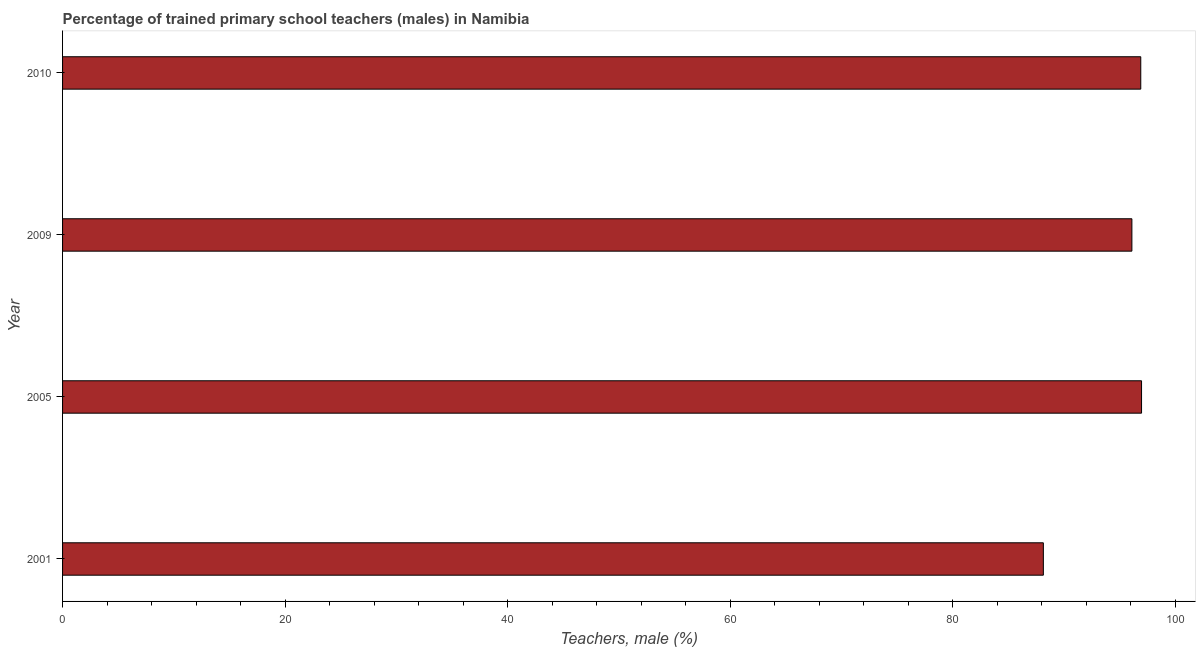Does the graph contain grids?
Give a very brief answer. No. What is the title of the graph?
Your answer should be compact. Percentage of trained primary school teachers (males) in Namibia. What is the label or title of the X-axis?
Offer a very short reply. Teachers, male (%). What is the label or title of the Y-axis?
Make the answer very short. Year. What is the percentage of trained male teachers in 2010?
Keep it short and to the point. 96.92. Across all years, what is the maximum percentage of trained male teachers?
Offer a very short reply. 96.99. Across all years, what is the minimum percentage of trained male teachers?
Keep it short and to the point. 88.16. What is the sum of the percentage of trained male teachers?
Your answer should be compact. 378.19. What is the difference between the percentage of trained male teachers in 2005 and 2009?
Ensure brevity in your answer.  0.87. What is the average percentage of trained male teachers per year?
Offer a very short reply. 94.55. What is the median percentage of trained male teachers?
Keep it short and to the point. 96.52. Do a majority of the years between 2001 and 2005 (inclusive) have percentage of trained male teachers greater than 32 %?
Give a very brief answer. Yes. What is the ratio of the percentage of trained male teachers in 2001 to that in 2010?
Offer a very short reply. 0.91. Is the difference between the percentage of trained male teachers in 2001 and 2005 greater than the difference between any two years?
Your response must be concise. Yes. What is the difference between the highest and the second highest percentage of trained male teachers?
Make the answer very short. 0.07. Is the sum of the percentage of trained male teachers in 2001 and 2009 greater than the maximum percentage of trained male teachers across all years?
Provide a succinct answer. Yes. What is the difference between the highest and the lowest percentage of trained male teachers?
Offer a terse response. 8.83. In how many years, is the percentage of trained male teachers greater than the average percentage of trained male teachers taken over all years?
Offer a terse response. 3. What is the Teachers, male (%) of 2001?
Offer a terse response. 88.16. What is the Teachers, male (%) of 2005?
Keep it short and to the point. 96.99. What is the Teachers, male (%) of 2009?
Your answer should be very brief. 96.12. What is the Teachers, male (%) in 2010?
Ensure brevity in your answer.  96.92. What is the difference between the Teachers, male (%) in 2001 and 2005?
Your answer should be compact. -8.83. What is the difference between the Teachers, male (%) in 2001 and 2009?
Give a very brief answer. -7.96. What is the difference between the Teachers, male (%) in 2001 and 2010?
Your response must be concise. -8.76. What is the difference between the Teachers, male (%) in 2005 and 2009?
Offer a very short reply. 0.87. What is the difference between the Teachers, male (%) in 2005 and 2010?
Keep it short and to the point. 0.07. What is the difference between the Teachers, male (%) in 2009 and 2010?
Make the answer very short. -0.8. What is the ratio of the Teachers, male (%) in 2001 to that in 2005?
Provide a succinct answer. 0.91. What is the ratio of the Teachers, male (%) in 2001 to that in 2009?
Ensure brevity in your answer.  0.92. What is the ratio of the Teachers, male (%) in 2001 to that in 2010?
Offer a very short reply. 0.91. What is the ratio of the Teachers, male (%) in 2009 to that in 2010?
Ensure brevity in your answer.  0.99. 